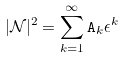<formula> <loc_0><loc_0><loc_500><loc_500>| { \mathcal { N } } | ^ { 2 } = \sum _ { k = 1 } ^ { \infty } \mathtt A _ { k } \epsilon ^ { k }</formula> 